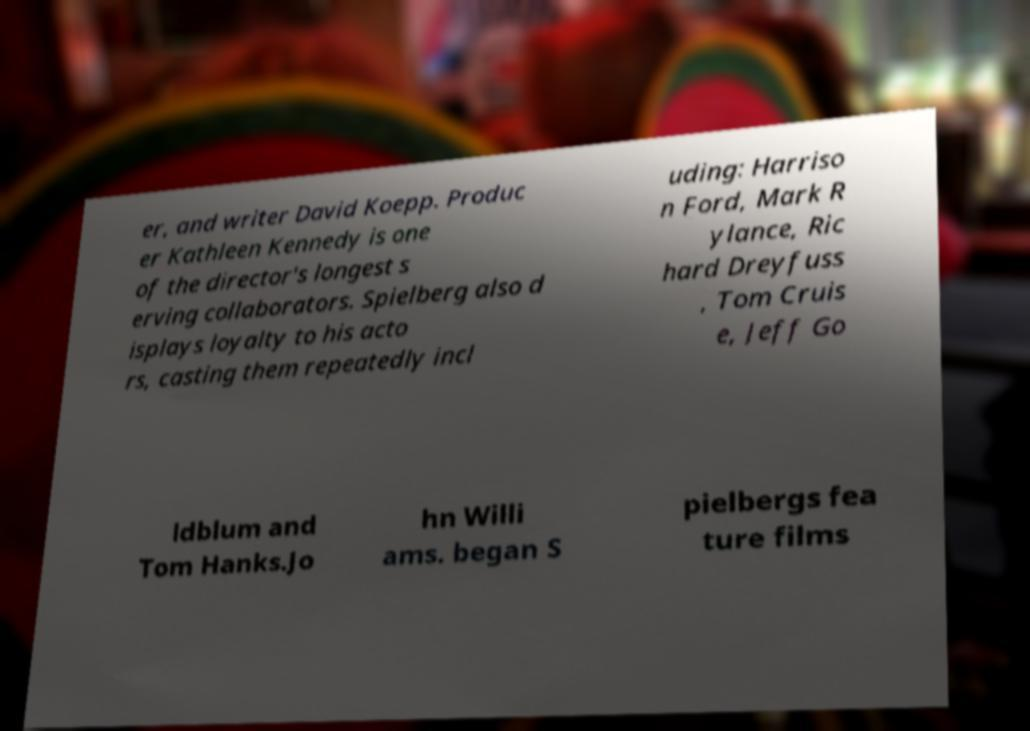Could you extract and type out the text from this image? er, and writer David Koepp. Produc er Kathleen Kennedy is one of the director's longest s erving collaborators. Spielberg also d isplays loyalty to his acto rs, casting them repeatedly incl uding: Harriso n Ford, Mark R ylance, Ric hard Dreyfuss , Tom Cruis e, Jeff Go ldblum and Tom Hanks.Jo hn Willi ams. began S pielbergs fea ture films 